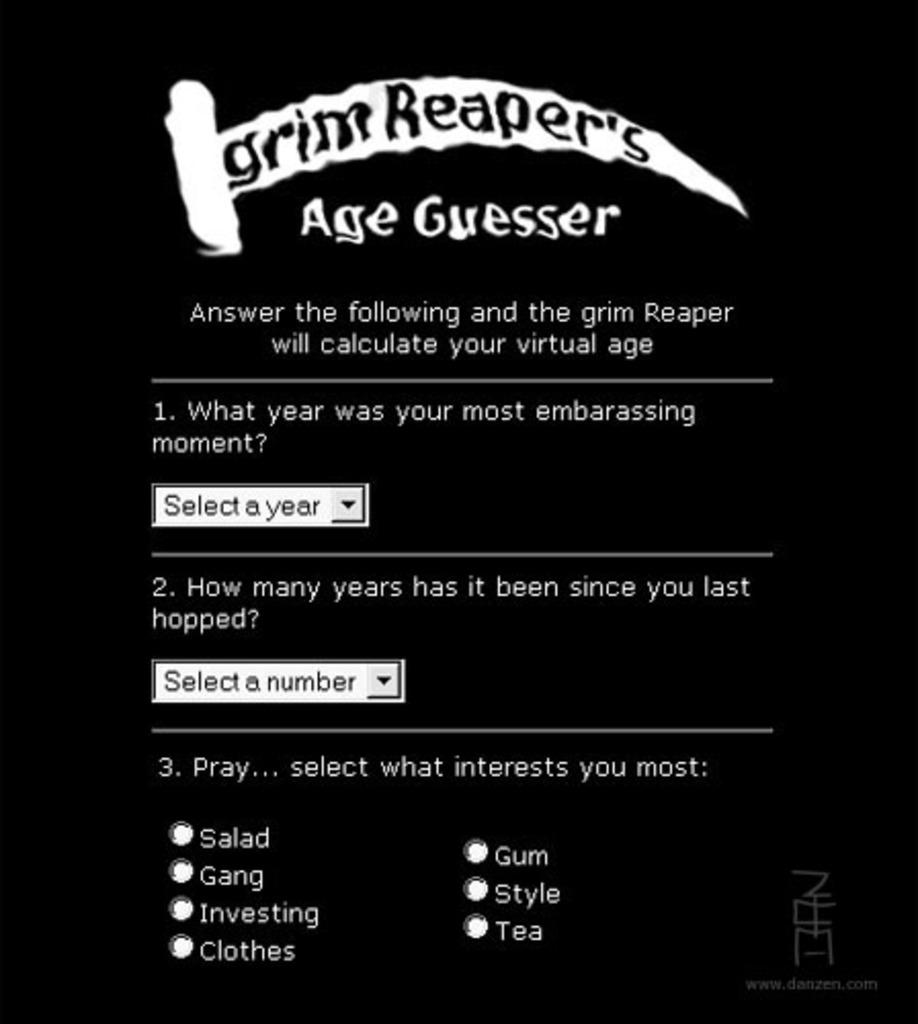What is the color of the background in the image? The image has a black background. What can be found in the image besides the background? There is text and interactive elements such as dropdown boxes and radio buttons in the image. How many types of interactive elements are present in the image? There are two types of interactive elements: dropdown boxes and radio buttons. What type of bun is being used to hold the text in the image? There is no bun present in the image; it contains text and interactive elements on a black background. Who is the expert featured in the image? There is no expert featured in the image; it contains text and interactive elements on a black background. 